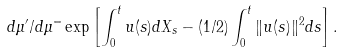<formula> <loc_0><loc_0><loc_500><loc_500>d \mu ^ { \prime } / d \mu ^ { = } \exp \left [ \int _ { 0 } ^ { t } u ( s ) d X _ { s } - ( 1 / 2 ) \int _ { 0 } ^ { t } \| u ( s ) \| ^ { 2 } d s \right ] .</formula> 